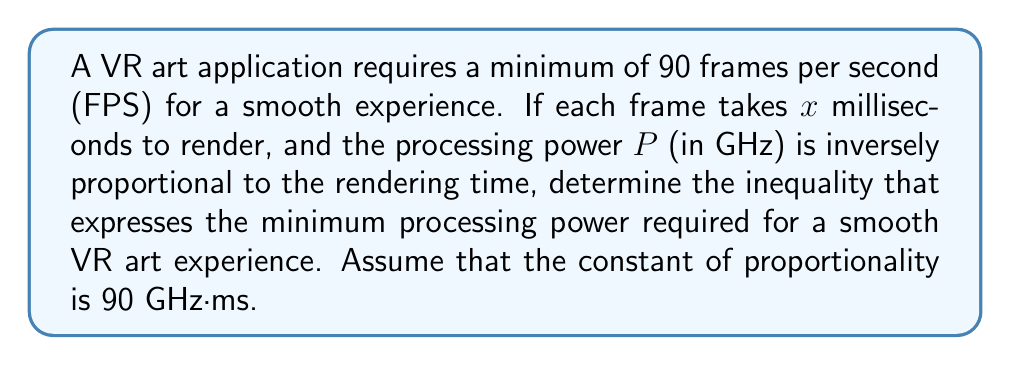Help me with this question. Let's approach this step-by-step:

1) First, we need to convert FPS to time per frame:
   90 FPS means each frame should take at most $\frac{1000}{90} \approx 11.11$ ms

2) We're given that each frame takes $x$ ms to render. For a smooth experience:
   $x \leq 11.11$

3) We're also told that the processing power $P$ is inversely proportional to the rendering time $x$:
   $P = \frac{k}{x}$, where $k$ is the constant of proportionality (90 GHz·ms)

4) Substituting the maximum acceptable value for $x$:
   $P \geq \frac{90}{11.11} \approx 8.10$ GHz

5) Therefore, the inequality expressing the minimum processing power is:
   $P \geq \frac{90}{x}$, where $x \leq 11.11$

6) Combining these conditions:
   $P \geq \frac{90}{x}$ and $x \leq 11.11$

7) We can eliminate $x$ by using the most restrictive case (when $x = 11.11$):
   $P \geq \frac{90}{11.11} \approx 8.10$ GHz
Answer: $P \geq 8.10$ GHz 